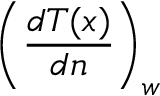<formula> <loc_0><loc_0><loc_500><loc_500>\left ( \frac { d T ( x ) } { d n } \right ) _ { w }</formula> 